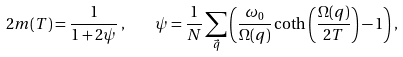Convert formula to latex. <formula><loc_0><loc_0><loc_500><loc_500>2 m ( T ) = \frac { 1 } { 1 + 2 \psi } \, , \quad \psi = \frac { 1 } { N } \sum _ { \vec { q } } \left ( \frac { \omega _ { 0 } } { \Omega ( q ) } \coth \left ( \frac { \Omega ( q ) } { 2 T } \right ) - 1 \right ) ,</formula> 